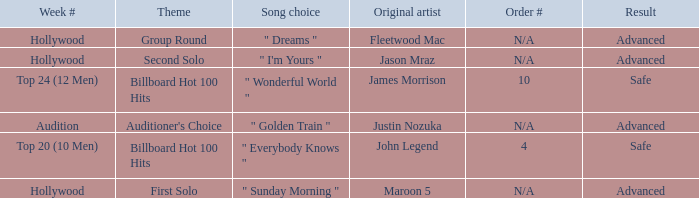What are all the topic wherein music preference is " golden train " Auditioner's Choice. 